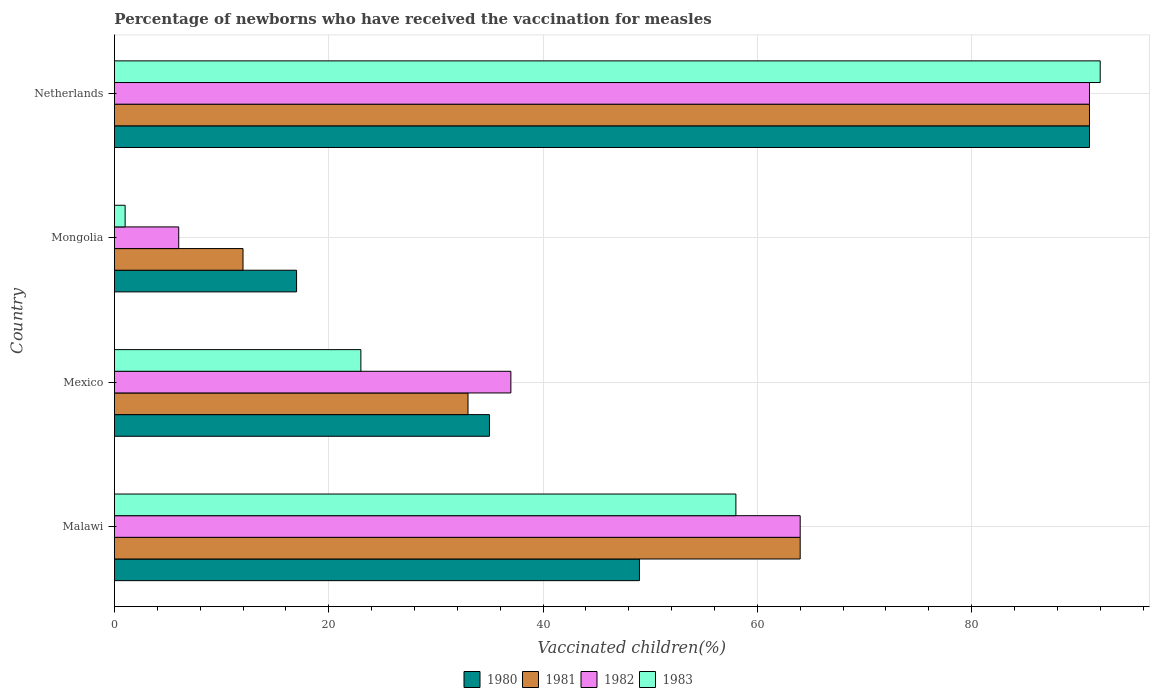How many different coloured bars are there?
Make the answer very short. 4. How many bars are there on the 4th tick from the bottom?
Your answer should be very brief. 4. In how many cases, is the number of bars for a given country not equal to the number of legend labels?
Make the answer very short. 0. What is the percentage of vaccinated children in 1980 in Netherlands?
Your response must be concise. 91. Across all countries, what is the maximum percentage of vaccinated children in 1983?
Your response must be concise. 92. In which country was the percentage of vaccinated children in 1981 minimum?
Provide a succinct answer. Mongolia. What is the total percentage of vaccinated children in 1982 in the graph?
Your response must be concise. 198. What is the difference between the percentage of vaccinated children in 1983 in Malawi and that in Mexico?
Offer a terse response. 35. What is the difference between the percentage of vaccinated children in 1983 in Mexico and the percentage of vaccinated children in 1981 in Netherlands?
Provide a short and direct response. -68. In how many countries, is the percentage of vaccinated children in 1983 greater than 80 %?
Your answer should be very brief. 1. What is the ratio of the percentage of vaccinated children in 1983 in Malawi to that in Netherlands?
Your answer should be compact. 0.63. Is the percentage of vaccinated children in 1983 in Mongolia less than that in Netherlands?
Provide a succinct answer. Yes. What is the difference between the highest and the second highest percentage of vaccinated children in 1980?
Provide a short and direct response. 42. What is the difference between the highest and the lowest percentage of vaccinated children in 1983?
Make the answer very short. 91. What does the 2nd bar from the bottom in Mexico represents?
Keep it short and to the point. 1981. Is it the case that in every country, the sum of the percentage of vaccinated children in 1982 and percentage of vaccinated children in 1983 is greater than the percentage of vaccinated children in 1980?
Keep it short and to the point. No. Are all the bars in the graph horizontal?
Your answer should be very brief. Yes. What is the difference between two consecutive major ticks on the X-axis?
Your answer should be compact. 20. Are the values on the major ticks of X-axis written in scientific E-notation?
Your answer should be very brief. No. Does the graph contain any zero values?
Ensure brevity in your answer.  No. Does the graph contain grids?
Provide a succinct answer. Yes. How many legend labels are there?
Keep it short and to the point. 4. How are the legend labels stacked?
Give a very brief answer. Horizontal. What is the title of the graph?
Provide a succinct answer. Percentage of newborns who have received the vaccination for measles. Does "1990" appear as one of the legend labels in the graph?
Give a very brief answer. No. What is the label or title of the X-axis?
Keep it short and to the point. Vaccinated children(%). What is the Vaccinated children(%) of 1980 in Malawi?
Give a very brief answer. 49. What is the Vaccinated children(%) of 1981 in Malawi?
Offer a terse response. 64. What is the Vaccinated children(%) of 1982 in Mexico?
Your answer should be very brief. 37. What is the Vaccinated children(%) of 1983 in Mexico?
Ensure brevity in your answer.  23. What is the Vaccinated children(%) in 1983 in Mongolia?
Keep it short and to the point. 1. What is the Vaccinated children(%) of 1980 in Netherlands?
Provide a short and direct response. 91. What is the Vaccinated children(%) of 1981 in Netherlands?
Your answer should be compact. 91. What is the Vaccinated children(%) of 1982 in Netherlands?
Your response must be concise. 91. What is the Vaccinated children(%) in 1983 in Netherlands?
Your response must be concise. 92. Across all countries, what is the maximum Vaccinated children(%) of 1980?
Ensure brevity in your answer.  91. Across all countries, what is the maximum Vaccinated children(%) in 1981?
Your answer should be very brief. 91. Across all countries, what is the maximum Vaccinated children(%) in 1982?
Your response must be concise. 91. Across all countries, what is the maximum Vaccinated children(%) of 1983?
Your response must be concise. 92. Across all countries, what is the minimum Vaccinated children(%) in 1980?
Give a very brief answer. 17. Across all countries, what is the minimum Vaccinated children(%) in 1981?
Offer a very short reply. 12. Across all countries, what is the minimum Vaccinated children(%) of 1983?
Your answer should be compact. 1. What is the total Vaccinated children(%) of 1980 in the graph?
Ensure brevity in your answer.  192. What is the total Vaccinated children(%) in 1981 in the graph?
Your answer should be very brief. 200. What is the total Vaccinated children(%) of 1982 in the graph?
Offer a very short reply. 198. What is the total Vaccinated children(%) in 1983 in the graph?
Give a very brief answer. 174. What is the difference between the Vaccinated children(%) in 1981 in Malawi and that in Mexico?
Give a very brief answer. 31. What is the difference between the Vaccinated children(%) in 1983 in Malawi and that in Mexico?
Your answer should be very brief. 35. What is the difference between the Vaccinated children(%) of 1982 in Malawi and that in Mongolia?
Provide a succinct answer. 58. What is the difference between the Vaccinated children(%) in 1983 in Malawi and that in Mongolia?
Keep it short and to the point. 57. What is the difference between the Vaccinated children(%) of 1980 in Malawi and that in Netherlands?
Provide a short and direct response. -42. What is the difference between the Vaccinated children(%) of 1982 in Malawi and that in Netherlands?
Offer a terse response. -27. What is the difference between the Vaccinated children(%) of 1983 in Malawi and that in Netherlands?
Make the answer very short. -34. What is the difference between the Vaccinated children(%) of 1980 in Mexico and that in Mongolia?
Make the answer very short. 18. What is the difference between the Vaccinated children(%) of 1980 in Mexico and that in Netherlands?
Provide a short and direct response. -56. What is the difference between the Vaccinated children(%) in 1981 in Mexico and that in Netherlands?
Make the answer very short. -58. What is the difference between the Vaccinated children(%) in 1982 in Mexico and that in Netherlands?
Offer a very short reply. -54. What is the difference between the Vaccinated children(%) of 1983 in Mexico and that in Netherlands?
Your response must be concise. -69. What is the difference between the Vaccinated children(%) in 1980 in Mongolia and that in Netherlands?
Give a very brief answer. -74. What is the difference between the Vaccinated children(%) of 1981 in Mongolia and that in Netherlands?
Offer a very short reply. -79. What is the difference between the Vaccinated children(%) of 1982 in Mongolia and that in Netherlands?
Provide a short and direct response. -85. What is the difference between the Vaccinated children(%) of 1983 in Mongolia and that in Netherlands?
Provide a short and direct response. -91. What is the difference between the Vaccinated children(%) in 1980 in Malawi and the Vaccinated children(%) in 1981 in Mexico?
Provide a succinct answer. 16. What is the difference between the Vaccinated children(%) of 1980 in Malawi and the Vaccinated children(%) of 1982 in Mexico?
Give a very brief answer. 12. What is the difference between the Vaccinated children(%) in 1980 in Malawi and the Vaccinated children(%) in 1983 in Mexico?
Your response must be concise. 26. What is the difference between the Vaccinated children(%) of 1981 in Malawi and the Vaccinated children(%) of 1982 in Mexico?
Make the answer very short. 27. What is the difference between the Vaccinated children(%) of 1981 in Malawi and the Vaccinated children(%) of 1982 in Mongolia?
Your answer should be compact. 58. What is the difference between the Vaccinated children(%) in 1981 in Malawi and the Vaccinated children(%) in 1983 in Mongolia?
Provide a short and direct response. 63. What is the difference between the Vaccinated children(%) of 1980 in Malawi and the Vaccinated children(%) of 1981 in Netherlands?
Provide a short and direct response. -42. What is the difference between the Vaccinated children(%) in 1980 in Malawi and the Vaccinated children(%) in 1982 in Netherlands?
Give a very brief answer. -42. What is the difference between the Vaccinated children(%) of 1980 in Malawi and the Vaccinated children(%) of 1983 in Netherlands?
Provide a succinct answer. -43. What is the difference between the Vaccinated children(%) of 1981 in Malawi and the Vaccinated children(%) of 1982 in Netherlands?
Your response must be concise. -27. What is the difference between the Vaccinated children(%) in 1981 in Malawi and the Vaccinated children(%) in 1983 in Netherlands?
Your answer should be compact. -28. What is the difference between the Vaccinated children(%) of 1980 in Mexico and the Vaccinated children(%) of 1981 in Mongolia?
Offer a very short reply. 23. What is the difference between the Vaccinated children(%) in 1981 in Mexico and the Vaccinated children(%) in 1982 in Mongolia?
Your response must be concise. 27. What is the difference between the Vaccinated children(%) of 1980 in Mexico and the Vaccinated children(%) of 1981 in Netherlands?
Your response must be concise. -56. What is the difference between the Vaccinated children(%) of 1980 in Mexico and the Vaccinated children(%) of 1982 in Netherlands?
Offer a terse response. -56. What is the difference between the Vaccinated children(%) of 1980 in Mexico and the Vaccinated children(%) of 1983 in Netherlands?
Offer a very short reply. -57. What is the difference between the Vaccinated children(%) of 1981 in Mexico and the Vaccinated children(%) of 1982 in Netherlands?
Ensure brevity in your answer.  -58. What is the difference between the Vaccinated children(%) of 1981 in Mexico and the Vaccinated children(%) of 1983 in Netherlands?
Offer a very short reply. -59. What is the difference between the Vaccinated children(%) in 1982 in Mexico and the Vaccinated children(%) in 1983 in Netherlands?
Provide a succinct answer. -55. What is the difference between the Vaccinated children(%) of 1980 in Mongolia and the Vaccinated children(%) of 1981 in Netherlands?
Ensure brevity in your answer.  -74. What is the difference between the Vaccinated children(%) of 1980 in Mongolia and the Vaccinated children(%) of 1982 in Netherlands?
Offer a terse response. -74. What is the difference between the Vaccinated children(%) in 1980 in Mongolia and the Vaccinated children(%) in 1983 in Netherlands?
Offer a very short reply. -75. What is the difference between the Vaccinated children(%) in 1981 in Mongolia and the Vaccinated children(%) in 1982 in Netherlands?
Keep it short and to the point. -79. What is the difference between the Vaccinated children(%) in 1981 in Mongolia and the Vaccinated children(%) in 1983 in Netherlands?
Ensure brevity in your answer.  -80. What is the difference between the Vaccinated children(%) in 1982 in Mongolia and the Vaccinated children(%) in 1983 in Netherlands?
Your answer should be very brief. -86. What is the average Vaccinated children(%) in 1980 per country?
Give a very brief answer. 48. What is the average Vaccinated children(%) in 1981 per country?
Ensure brevity in your answer.  50. What is the average Vaccinated children(%) of 1982 per country?
Keep it short and to the point. 49.5. What is the average Vaccinated children(%) in 1983 per country?
Ensure brevity in your answer.  43.5. What is the difference between the Vaccinated children(%) of 1980 and Vaccinated children(%) of 1983 in Malawi?
Provide a succinct answer. -9. What is the difference between the Vaccinated children(%) in 1981 and Vaccinated children(%) in 1982 in Malawi?
Provide a succinct answer. 0. What is the difference between the Vaccinated children(%) in 1981 and Vaccinated children(%) in 1983 in Malawi?
Your answer should be compact. 6. What is the difference between the Vaccinated children(%) of 1982 and Vaccinated children(%) of 1983 in Malawi?
Keep it short and to the point. 6. What is the difference between the Vaccinated children(%) in 1980 and Vaccinated children(%) in 1981 in Mexico?
Provide a short and direct response. 2. What is the difference between the Vaccinated children(%) of 1980 and Vaccinated children(%) of 1981 in Mongolia?
Your answer should be compact. 5. What is the difference between the Vaccinated children(%) of 1980 and Vaccinated children(%) of 1981 in Netherlands?
Your answer should be very brief. 0. What is the difference between the Vaccinated children(%) of 1980 and Vaccinated children(%) of 1983 in Netherlands?
Keep it short and to the point. -1. What is the ratio of the Vaccinated children(%) in 1981 in Malawi to that in Mexico?
Your response must be concise. 1.94. What is the ratio of the Vaccinated children(%) of 1982 in Malawi to that in Mexico?
Ensure brevity in your answer.  1.73. What is the ratio of the Vaccinated children(%) of 1983 in Malawi to that in Mexico?
Provide a succinct answer. 2.52. What is the ratio of the Vaccinated children(%) of 1980 in Malawi to that in Mongolia?
Offer a very short reply. 2.88. What is the ratio of the Vaccinated children(%) in 1981 in Malawi to that in Mongolia?
Provide a succinct answer. 5.33. What is the ratio of the Vaccinated children(%) in 1982 in Malawi to that in Mongolia?
Make the answer very short. 10.67. What is the ratio of the Vaccinated children(%) in 1983 in Malawi to that in Mongolia?
Your answer should be very brief. 58. What is the ratio of the Vaccinated children(%) of 1980 in Malawi to that in Netherlands?
Offer a terse response. 0.54. What is the ratio of the Vaccinated children(%) of 1981 in Malawi to that in Netherlands?
Your answer should be very brief. 0.7. What is the ratio of the Vaccinated children(%) in 1982 in Malawi to that in Netherlands?
Keep it short and to the point. 0.7. What is the ratio of the Vaccinated children(%) in 1983 in Malawi to that in Netherlands?
Your answer should be very brief. 0.63. What is the ratio of the Vaccinated children(%) of 1980 in Mexico to that in Mongolia?
Your answer should be compact. 2.06. What is the ratio of the Vaccinated children(%) of 1981 in Mexico to that in Mongolia?
Keep it short and to the point. 2.75. What is the ratio of the Vaccinated children(%) of 1982 in Mexico to that in Mongolia?
Offer a terse response. 6.17. What is the ratio of the Vaccinated children(%) in 1983 in Mexico to that in Mongolia?
Give a very brief answer. 23. What is the ratio of the Vaccinated children(%) of 1980 in Mexico to that in Netherlands?
Give a very brief answer. 0.38. What is the ratio of the Vaccinated children(%) in 1981 in Mexico to that in Netherlands?
Make the answer very short. 0.36. What is the ratio of the Vaccinated children(%) in 1982 in Mexico to that in Netherlands?
Your answer should be compact. 0.41. What is the ratio of the Vaccinated children(%) in 1983 in Mexico to that in Netherlands?
Your answer should be compact. 0.25. What is the ratio of the Vaccinated children(%) in 1980 in Mongolia to that in Netherlands?
Give a very brief answer. 0.19. What is the ratio of the Vaccinated children(%) in 1981 in Mongolia to that in Netherlands?
Make the answer very short. 0.13. What is the ratio of the Vaccinated children(%) in 1982 in Mongolia to that in Netherlands?
Give a very brief answer. 0.07. What is the ratio of the Vaccinated children(%) of 1983 in Mongolia to that in Netherlands?
Give a very brief answer. 0.01. What is the difference between the highest and the second highest Vaccinated children(%) of 1981?
Offer a very short reply. 27. What is the difference between the highest and the lowest Vaccinated children(%) in 1981?
Ensure brevity in your answer.  79. What is the difference between the highest and the lowest Vaccinated children(%) in 1983?
Ensure brevity in your answer.  91. 